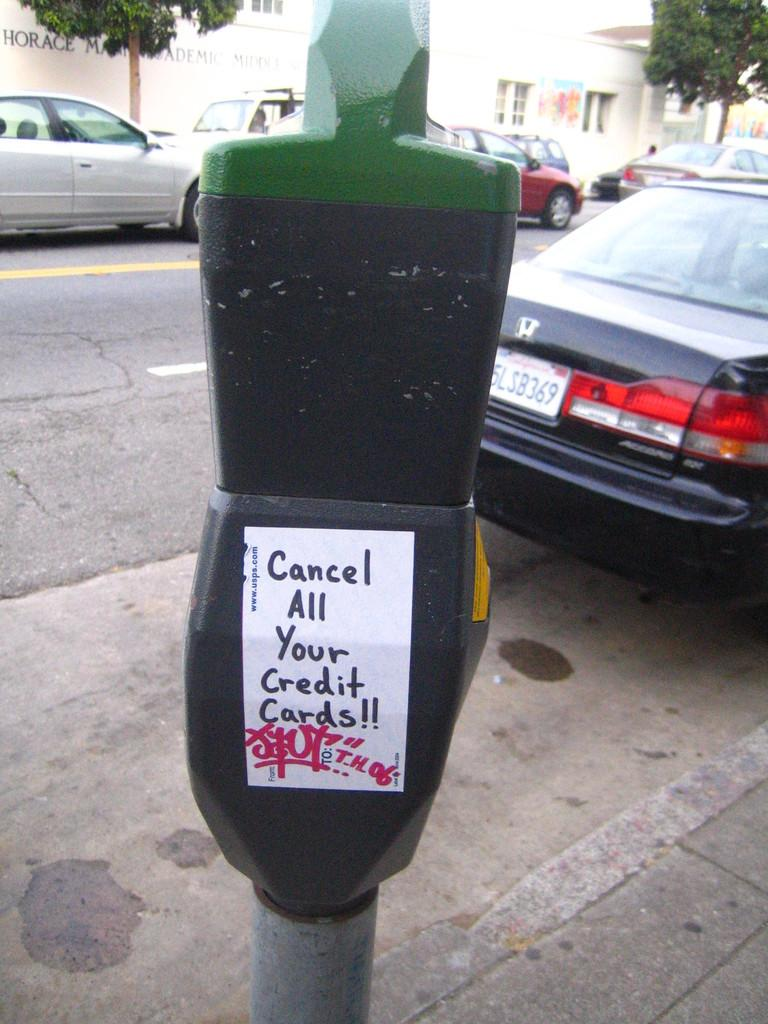Provide a one-sentence caption for the provided image. A sticker saying cancel all your credit cards is stuck to a parking meter. 